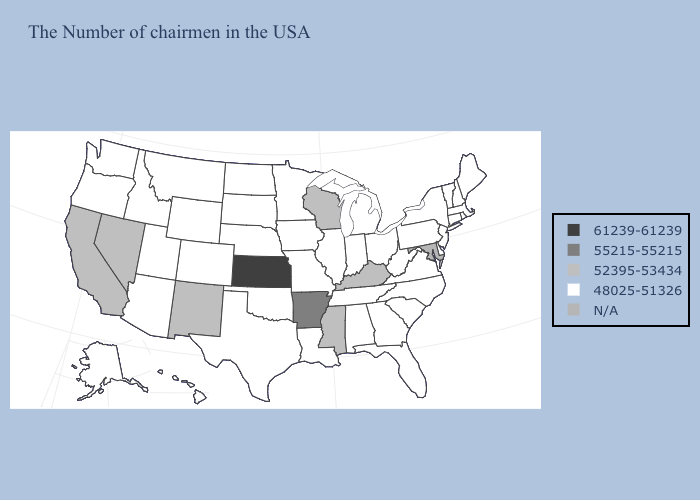What is the value of Idaho?
Give a very brief answer. 48025-51326. What is the value of Minnesota?
Short answer required. 48025-51326. Name the states that have a value in the range 55215-55215?
Short answer required. Arkansas. Name the states that have a value in the range 55215-55215?
Be succinct. Arkansas. Among the states that border Massachusetts , which have the lowest value?
Write a very short answer. Rhode Island, New Hampshire, Vermont, Connecticut, New York. Does Alaska have the highest value in the West?
Keep it brief. No. Among the states that border Iowa , does Illinois have the lowest value?
Concise answer only. Yes. Among the states that border New Jersey , which have the highest value?
Keep it brief. New York, Delaware, Pennsylvania. What is the lowest value in the Northeast?
Answer briefly. 48025-51326. What is the highest value in states that border Pennsylvania?
Be succinct. 48025-51326. Name the states that have a value in the range 48025-51326?
Quick response, please. Maine, Massachusetts, Rhode Island, New Hampshire, Vermont, Connecticut, New York, New Jersey, Delaware, Pennsylvania, Virginia, North Carolina, South Carolina, West Virginia, Ohio, Florida, Georgia, Michigan, Indiana, Alabama, Tennessee, Illinois, Louisiana, Missouri, Minnesota, Iowa, Nebraska, Oklahoma, Texas, South Dakota, North Dakota, Wyoming, Colorado, Utah, Montana, Arizona, Idaho, Washington, Oregon, Alaska, Hawaii. 